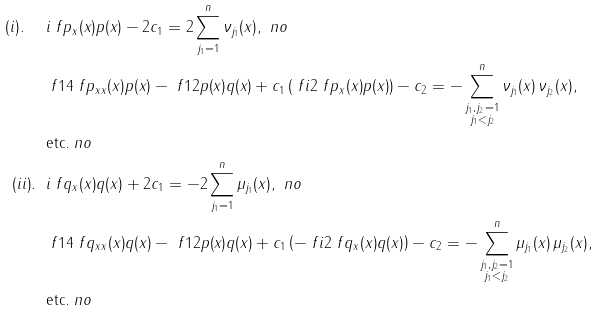<formula> <loc_0><loc_0><loc_500><loc_500>( i ) . \ \ & i \ f { p _ { x } ( x ) } { p ( x ) } - 2 c _ { 1 } = 2 \sum _ { j _ { 1 } = 1 } ^ { n } \nu _ { j _ { 1 } } ( x ) , \ n o \\ & \ f 1 4 \ f { p _ { x x } ( x ) } { p ( x ) } - \ f 1 2 p ( x ) q ( x ) + c _ { 1 } \left ( \ f { i } { 2 } \ f { p _ { x } ( x ) } { p ( x ) } \right ) - c _ { 2 } = - \sum _ { \substack { j _ { 1 } , j _ { 2 } = 1 \\ j _ { 1 } < j _ { 2 } } } ^ { n } \nu _ { j _ { 1 } } ( x ) \, \nu _ { j _ { 2 } } ( x ) , \\ & \text {etc.} \ n o \\ ( i i ) . \ \ & i \ f { q _ { x } ( x ) } { q ( x ) } + 2 c _ { 1 } = - 2 \sum _ { j _ { 1 } = 1 } ^ { n } \mu _ { j _ { 1 } } ( x ) , \ n o \\ & \ f 1 4 \ f { q _ { x x } ( x ) } { q ( x ) } - \ f 1 2 p ( x ) q ( x ) + c _ { 1 } \left ( - \ f { i } { 2 } \ f { q _ { x } ( x ) } { q ( x ) } \right ) - c _ { 2 } = - \sum _ { \substack { j _ { 1 } , j _ { 2 } = 1 \\ j _ { 1 } < j _ { 2 } } } ^ { n } \mu _ { j _ { 1 } } ( x ) \, \mu _ { j _ { 2 } } ( x ) , \\ & \text {etc.} \ n o</formula> 